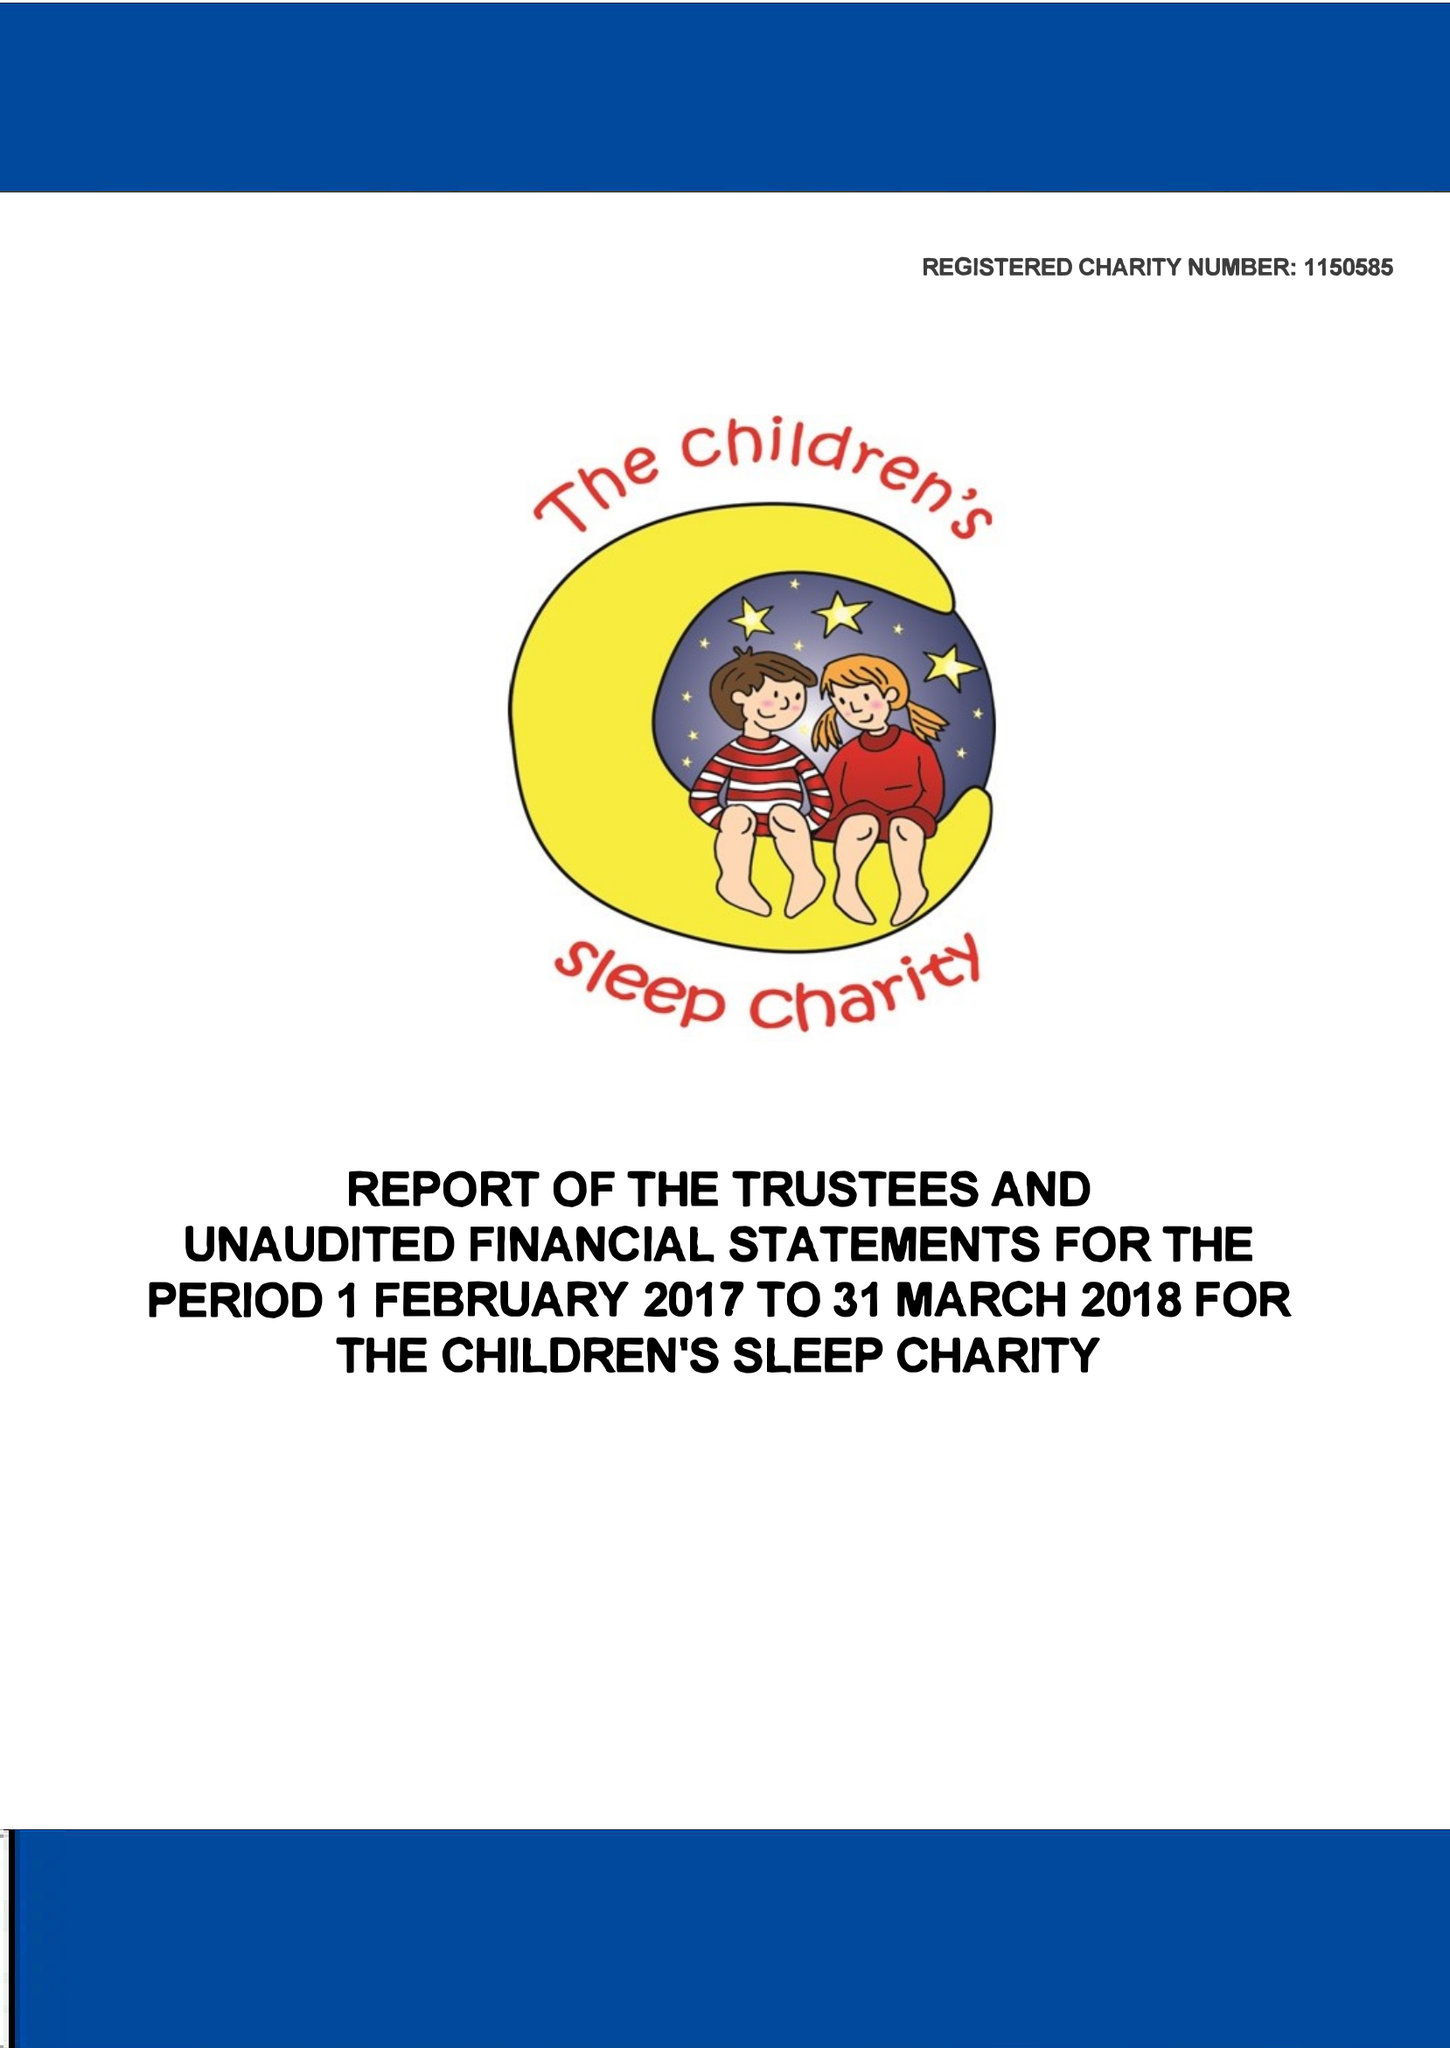What is the value for the spending_annually_in_british_pounds?
Answer the question using a single word or phrase. 315599.00 